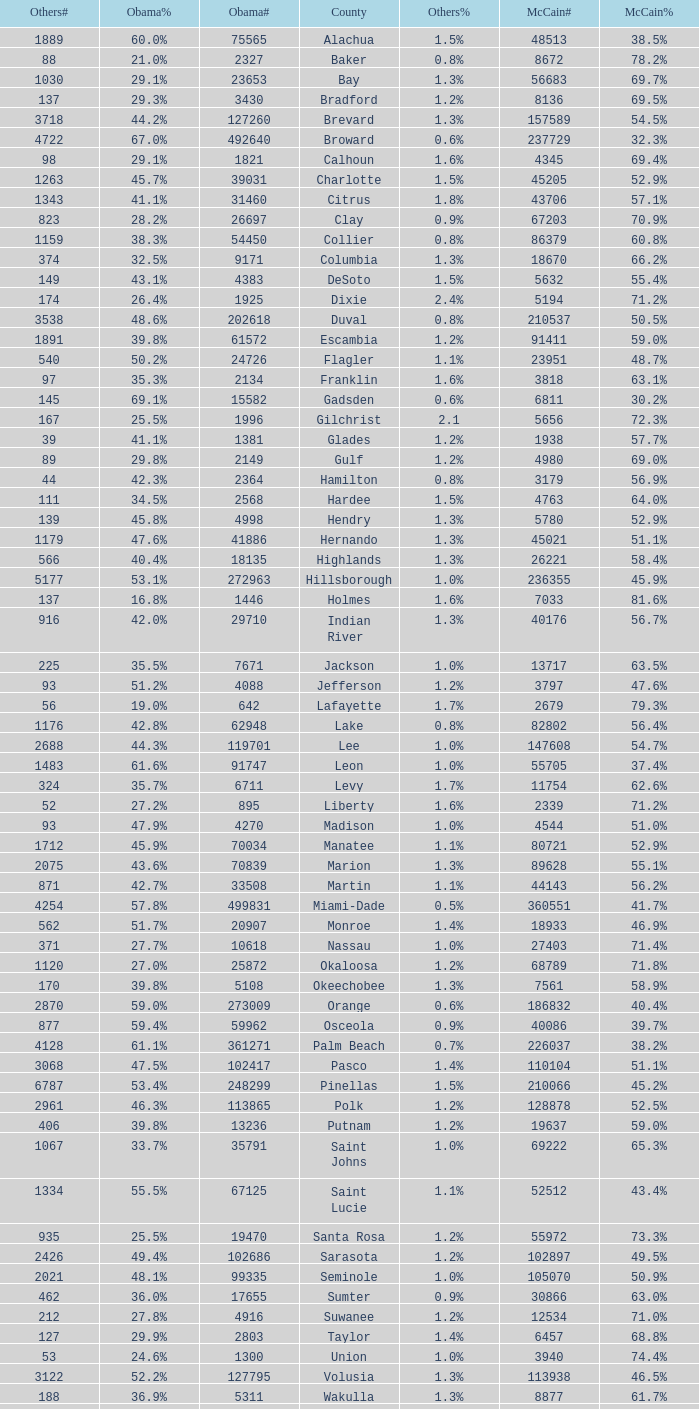What were the number of voters McCain had when Obama had 895? 2339.0. 